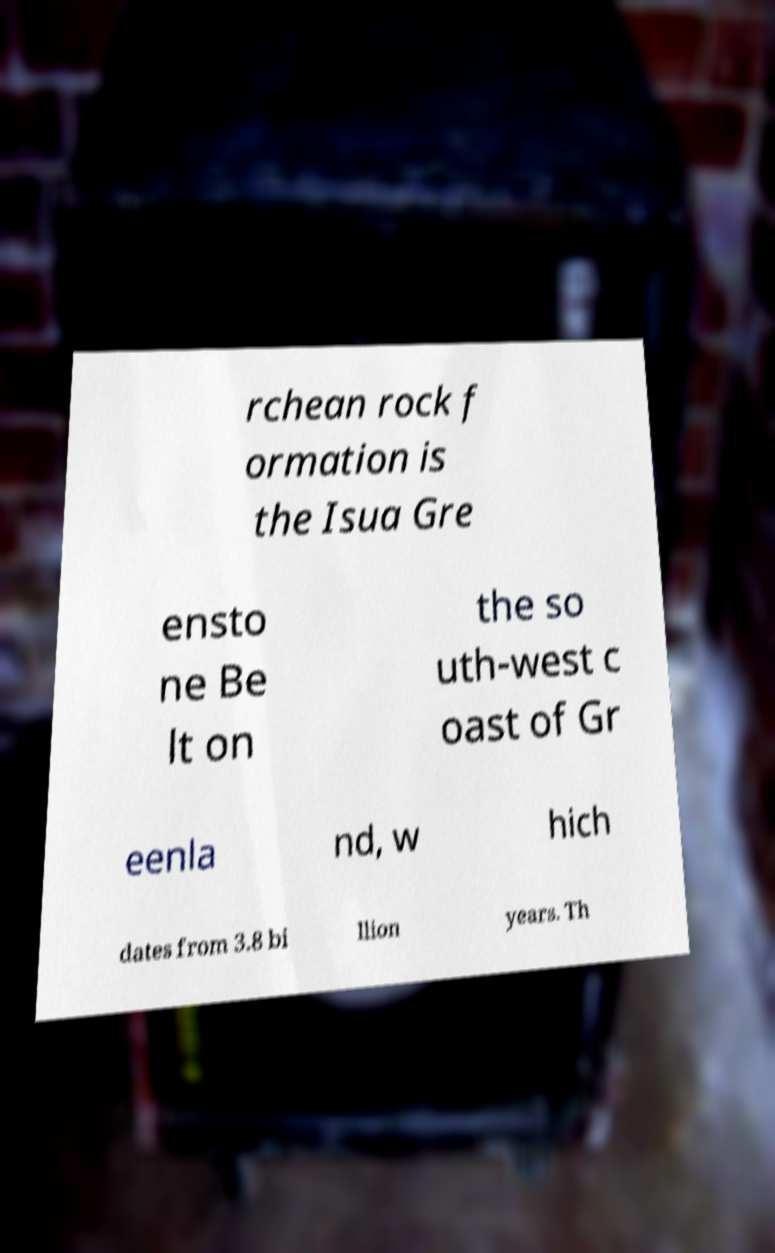There's text embedded in this image that I need extracted. Can you transcribe it verbatim? rchean rock f ormation is the Isua Gre ensto ne Be lt on the so uth-west c oast of Gr eenla nd, w hich dates from 3.8 bi llion years. Th 